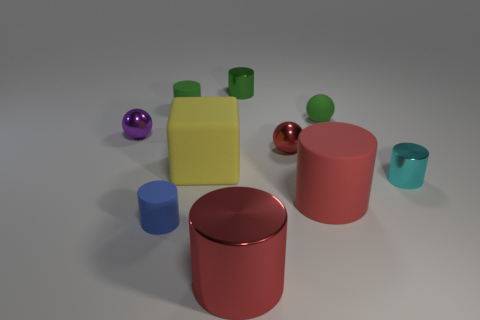There is a shiny sphere that is to the right of the large red metal object; is it the same color as the large cylinder left of the big red matte cylinder?
Your answer should be very brief. Yes. What material is the small cyan thing that is the same shape as the blue thing?
Offer a very short reply. Metal. What number of other things are the same shape as the big metal thing?
Provide a succinct answer. 5. How many tiny purple metallic spheres are in front of the metal cylinder in front of the rubber cylinder that is in front of the big rubber cylinder?
Ensure brevity in your answer.  0. What number of other green shiny objects are the same shape as the big metallic thing?
Offer a terse response. 1. There is a thing in front of the blue rubber cylinder; is it the same color as the large rubber cylinder?
Offer a terse response. Yes. There is a red metallic thing behind the red cylinder that is on the right side of the red metal thing that is in front of the red sphere; what is its shape?
Your answer should be compact. Sphere. There is a yellow matte thing; does it have the same size as the green matte object on the right side of the large red rubber cylinder?
Your answer should be compact. No. Is there a blue object that has the same size as the matte block?
Provide a short and direct response. No. What number of other objects are the same material as the tiny blue object?
Provide a succinct answer. 4. 